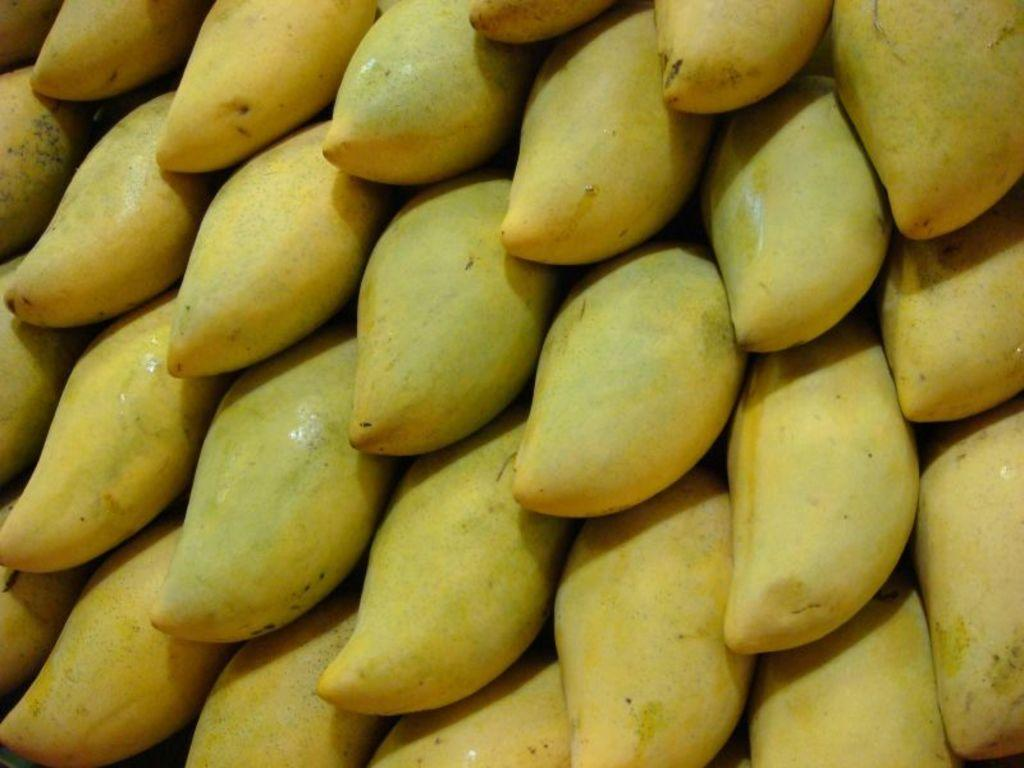What type of fruit is present in the image? There are mangoes in the image. Can you describe the color of the mangoes? The mangoes are in a greenish yellow color. Can you tell me how many tigers are visible in the image? There are no tigers present in the image; it features mangoes. What flavor of mangoes can be seen in the image? The flavor of the mangoes cannot be determined from the image alone, as the flavor is not visually discernible. 